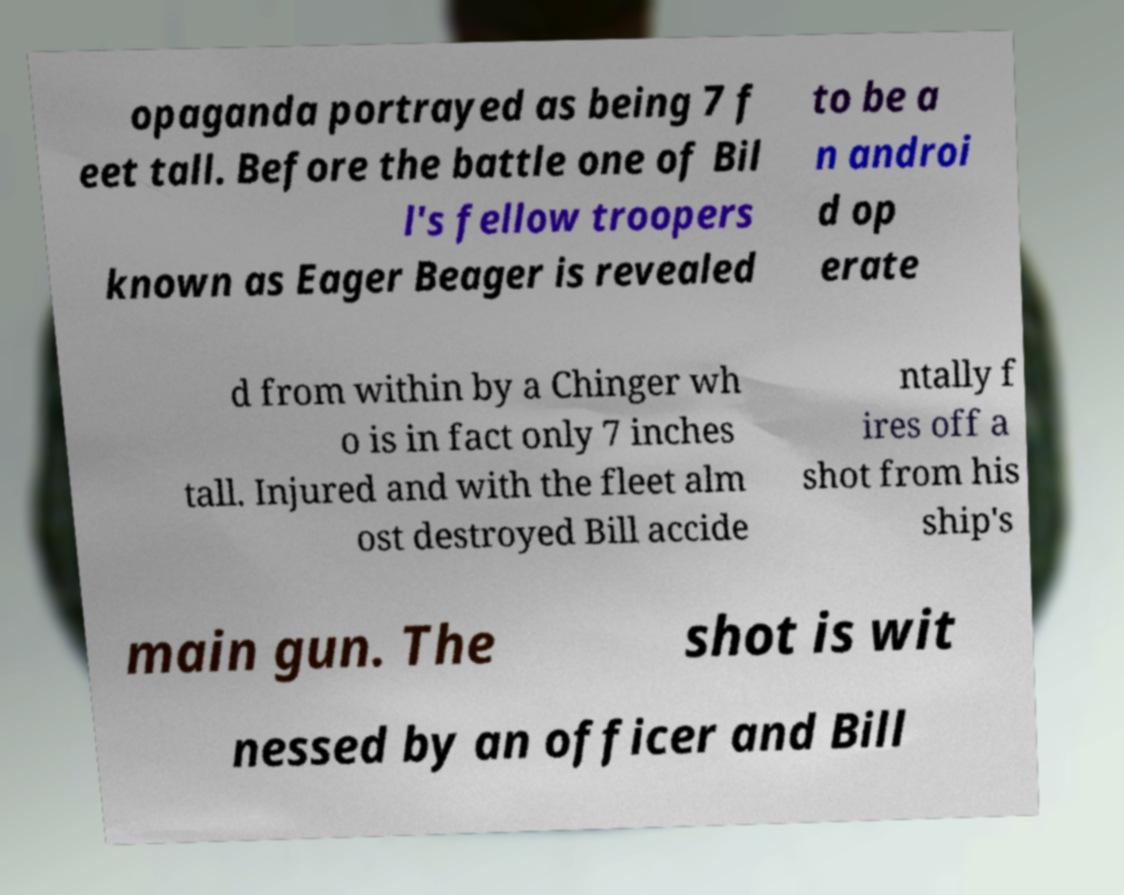Can you read and provide the text displayed in the image?This photo seems to have some interesting text. Can you extract and type it out for me? opaganda portrayed as being 7 f eet tall. Before the battle one of Bil l's fellow troopers known as Eager Beager is revealed to be a n androi d op erate d from within by a Chinger wh o is in fact only 7 inches tall. Injured and with the fleet alm ost destroyed Bill accide ntally f ires off a shot from his ship's main gun. The shot is wit nessed by an officer and Bill 